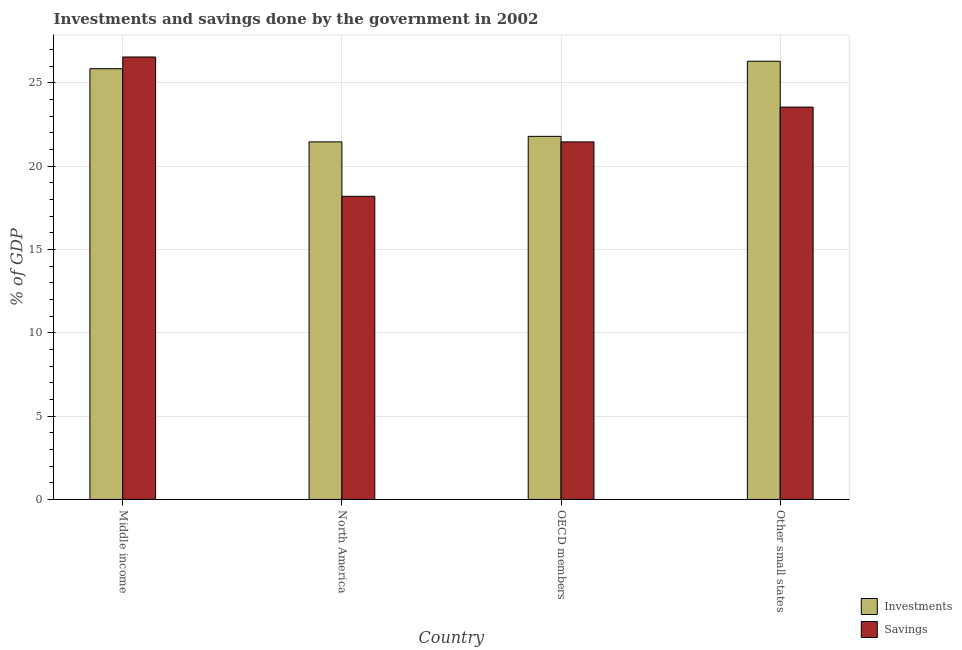How many different coloured bars are there?
Give a very brief answer. 2. How many bars are there on the 1st tick from the left?
Your response must be concise. 2. How many bars are there on the 3rd tick from the right?
Make the answer very short. 2. What is the label of the 4th group of bars from the left?
Provide a short and direct response. Other small states. In how many cases, is the number of bars for a given country not equal to the number of legend labels?
Your answer should be compact. 0. What is the savings of government in Other small states?
Your response must be concise. 23.54. Across all countries, what is the maximum investments of government?
Your response must be concise. 26.29. Across all countries, what is the minimum savings of government?
Provide a short and direct response. 18.19. In which country was the investments of government maximum?
Offer a terse response. Other small states. In which country was the savings of government minimum?
Make the answer very short. North America. What is the total investments of government in the graph?
Offer a terse response. 95.38. What is the difference between the investments of government in Middle income and that in OECD members?
Give a very brief answer. 4.06. What is the difference between the savings of government in OECD members and the investments of government in Other small states?
Make the answer very short. -4.84. What is the average investments of government per country?
Offer a terse response. 23.84. What is the difference between the savings of government and investments of government in Middle income?
Make the answer very short. 0.7. What is the ratio of the savings of government in North America to that in Other small states?
Offer a terse response. 0.77. Is the investments of government in North America less than that in OECD members?
Your answer should be very brief. Yes. Is the difference between the savings of government in OECD members and Other small states greater than the difference between the investments of government in OECD members and Other small states?
Your answer should be very brief. Yes. What is the difference between the highest and the second highest investments of government?
Your response must be concise. 0.45. What is the difference between the highest and the lowest investments of government?
Offer a terse response. 4.84. In how many countries, is the investments of government greater than the average investments of government taken over all countries?
Keep it short and to the point. 2. What does the 1st bar from the left in Middle income represents?
Your answer should be very brief. Investments. What does the 1st bar from the right in Other small states represents?
Ensure brevity in your answer.  Savings. What is the difference between two consecutive major ticks on the Y-axis?
Your answer should be very brief. 5. Does the graph contain grids?
Give a very brief answer. Yes. What is the title of the graph?
Give a very brief answer. Investments and savings done by the government in 2002. Does "Private funds" appear as one of the legend labels in the graph?
Ensure brevity in your answer.  No. What is the label or title of the Y-axis?
Ensure brevity in your answer.  % of GDP. What is the % of GDP of Investments in Middle income?
Offer a terse response. 25.85. What is the % of GDP of Savings in Middle income?
Your response must be concise. 26.55. What is the % of GDP of Investments in North America?
Offer a very short reply. 21.45. What is the % of GDP in Savings in North America?
Make the answer very short. 18.19. What is the % of GDP of Investments in OECD members?
Offer a very short reply. 21.79. What is the % of GDP in Savings in OECD members?
Your answer should be compact. 21.45. What is the % of GDP in Investments in Other small states?
Your answer should be very brief. 26.29. What is the % of GDP in Savings in Other small states?
Offer a very short reply. 23.54. Across all countries, what is the maximum % of GDP in Investments?
Keep it short and to the point. 26.29. Across all countries, what is the maximum % of GDP of Savings?
Offer a very short reply. 26.55. Across all countries, what is the minimum % of GDP of Investments?
Offer a very short reply. 21.45. Across all countries, what is the minimum % of GDP of Savings?
Offer a terse response. 18.19. What is the total % of GDP in Investments in the graph?
Offer a terse response. 95.38. What is the total % of GDP in Savings in the graph?
Ensure brevity in your answer.  89.73. What is the difference between the % of GDP of Investments in Middle income and that in North America?
Your answer should be compact. 4.39. What is the difference between the % of GDP in Savings in Middle income and that in North America?
Offer a terse response. 8.36. What is the difference between the % of GDP in Investments in Middle income and that in OECD members?
Provide a short and direct response. 4.06. What is the difference between the % of GDP of Savings in Middle income and that in OECD members?
Your answer should be very brief. 5.09. What is the difference between the % of GDP of Investments in Middle income and that in Other small states?
Your answer should be compact. -0.45. What is the difference between the % of GDP of Savings in Middle income and that in Other small states?
Your response must be concise. 3.01. What is the difference between the % of GDP of Investments in North America and that in OECD members?
Your answer should be very brief. -0.33. What is the difference between the % of GDP of Savings in North America and that in OECD members?
Offer a very short reply. -3.26. What is the difference between the % of GDP in Investments in North America and that in Other small states?
Keep it short and to the point. -4.84. What is the difference between the % of GDP in Savings in North America and that in Other small states?
Provide a succinct answer. -5.35. What is the difference between the % of GDP in Investments in OECD members and that in Other small states?
Give a very brief answer. -4.51. What is the difference between the % of GDP in Savings in OECD members and that in Other small states?
Your answer should be very brief. -2.09. What is the difference between the % of GDP in Investments in Middle income and the % of GDP in Savings in North America?
Offer a terse response. 7.66. What is the difference between the % of GDP in Investments in Middle income and the % of GDP in Savings in OECD members?
Give a very brief answer. 4.39. What is the difference between the % of GDP in Investments in Middle income and the % of GDP in Savings in Other small states?
Your response must be concise. 2.3. What is the difference between the % of GDP of Investments in North America and the % of GDP of Savings in OECD members?
Ensure brevity in your answer.  0. What is the difference between the % of GDP of Investments in North America and the % of GDP of Savings in Other small states?
Offer a terse response. -2.09. What is the difference between the % of GDP in Investments in OECD members and the % of GDP in Savings in Other small states?
Offer a terse response. -1.76. What is the average % of GDP in Investments per country?
Give a very brief answer. 23.84. What is the average % of GDP in Savings per country?
Make the answer very short. 22.43. What is the difference between the % of GDP in Investments and % of GDP in Savings in Middle income?
Your answer should be compact. -0.7. What is the difference between the % of GDP of Investments and % of GDP of Savings in North America?
Offer a very short reply. 3.27. What is the difference between the % of GDP of Investments and % of GDP of Savings in OECD members?
Give a very brief answer. 0.33. What is the difference between the % of GDP of Investments and % of GDP of Savings in Other small states?
Keep it short and to the point. 2.75. What is the ratio of the % of GDP of Investments in Middle income to that in North America?
Give a very brief answer. 1.2. What is the ratio of the % of GDP of Savings in Middle income to that in North America?
Keep it short and to the point. 1.46. What is the ratio of the % of GDP in Investments in Middle income to that in OECD members?
Keep it short and to the point. 1.19. What is the ratio of the % of GDP of Savings in Middle income to that in OECD members?
Provide a succinct answer. 1.24. What is the ratio of the % of GDP of Savings in Middle income to that in Other small states?
Offer a terse response. 1.13. What is the ratio of the % of GDP in Investments in North America to that in OECD members?
Offer a terse response. 0.98. What is the ratio of the % of GDP of Savings in North America to that in OECD members?
Provide a short and direct response. 0.85. What is the ratio of the % of GDP of Investments in North America to that in Other small states?
Make the answer very short. 0.82. What is the ratio of the % of GDP in Savings in North America to that in Other small states?
Provide a short and direct response. 0.77. What is the ratio of the % of GDP in Investments in OECD members to that in Other small states?
Provide a short and direct response. 0.83. What is the ratio of the % of GDP of Savings in OECD members to that in Other small states?
Give a very brief answer. 0.91. What is the difference between the highest and the second highest % of GDP in Investments?
Your answer should be very brief. 0.45. What is the difference between the highest and the second highest % of GDP of Savings?
Provide a short and direct response. 3.01. What is the difference between the highest and the lowest % of GDP in Investments?
Keep it short and to the point. 4.84. What is the difference between the highest and the lowest % of GDP of Savings?
Offer a very short reply. 8.36. 